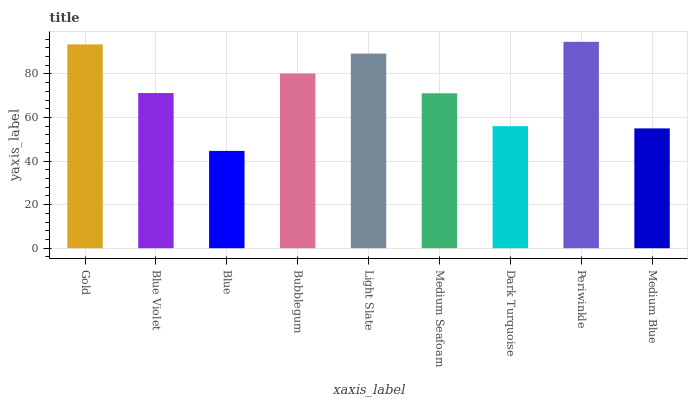Is Blue the minimum?
Answer yes or no. Yes. Is Periwinkle the maximum?
Answer yes or no. Yes. Is Blue Violet the minimum?
Answer yes or no. No. Is Blue Violet the maximum?
Answer yes or no. No. Is Gold greater than Blue Violet?
Answer yes or no. Yes. Is Blue Violet less than Gold?
Answer yes or no. Yes. Is Blue Violet greater than Gold?
Answer yes or no. No. Is Gold less than Blue Violet?
Answer yes or no. No. Is Blue Violet the high median?
Answer yes or no. Yes. Is Blue Violet the low median?
Answer yes or no. Yes. Is Dark Turquoise the high median?
Answer yes or no. No. Is Blue the low median?
Answer yes or no. No. 